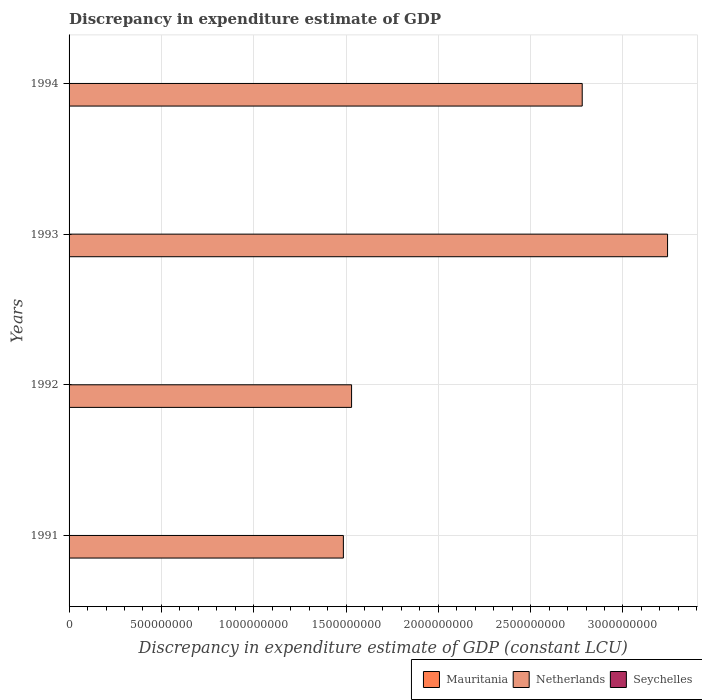How many different coloured bars are there?
Provide a succinct answer. 1. Are the number of bars per tick equal to the number of legend labels?
Offer a terse response. No. How many bars are there on the 4th tick from the bottom?
Keep it short and to the point. 1. In how many cases, is the number of bars for a given year not equal to the number of legend labels?
Provide a short and direct response. 4. Across all years, what is the maximum discrepancy in expenditure estimate of GDP in Netherlands?
Your response must be concise. 3.24e+09. What is the total discrepancy in expenditure estimate of GDP in Mauritania in the graph?
Make the answer very short. 0. What is the difference between the discrepancy in expenditure estimate of GDP in Netherlands in 1992 and that in 1993?
Keep it short and to the point. -1.71e+09. What is the difference between the discrepancy in expenditure estimate of GDP in Mauritania in 1992 and the discrepancy in expenditure estimate of GDP in Seychelles in 1994?
Your response must be concise. 0. What is the average discrepancy in expenditure estimate of GDP in Netherlands per year?
Keep it short and to the point. 2.26e+09. In how many years, is the discrepancy in expenditure estimate of GDP in Mauritania greater than 800000000 LCU?
Keep it short and to the point. 0. What is the difference between the highest and the second highest discrepancy in expenditure estimate of GDP in Netherlands?
Make the answer very short. 4.62e+08. What is the difference between the highest and the lowest discrepancy in expenditure estimate of GDP in Netherlands?
Your answer should be very brief. 1.76e+09. In how many years, is the discrepancy in expenditure estimate of GDP in Mauritania greater than the average discrepancy in expenditure estimate of GDP in Mauritania taken over all years?
Make the answer very short. 0. How many bars are there?
Your response must be concise. 4. Are all the bars in the graph horizontal?
Your response must be concise. Yes. Are the values on the major ticks of X-axis written in scientific E-notation?
Offer a very short reply. No. Does the graph contain any zero values?
Offer a very short reply. Yes. How are the legend labels stacked?
Your answer should be compact. Horizontal. What is the title of the graph?
Your response must be concise. Discrepancy in expenditure estimate of GDP. What is the label or title of the X-axis?
Your answer should be compact. Discrepancy in expenditure estimate of GDP (constant LCU). What is the label or title of the Y-axis?
Ensure brevity in your answer.  Years. What is the Discrepancy in expenditure estimate of GDP (constant LCU) in Mauritania in 1991?
Your response must be concise. 0. What is the Discrepancy in expenditure estimate of GDP (constant LCU) of Netherlands in 1991?
Ensure brevity in your answer.  1.49e+09. What is the Discrepancy in expenditure estimate of GDP (constant LCU) in Mauritania in 1992?
Provide a short and direct response. 0. What is the Discrepancy in expenditure estimate of GDP (constant LCU) in Netherlands in 1992?
Your response must be concise. 1.53e+09. What is the Discrepancy in expenditure estimate of GDP (constant LCU) in Seychelles in 1992?
Offer a very short reply. 0. What is the Discrepancy in expenditure estimate of GDP (constant LCU) in Netherlands in 1993?
Offer a very short reply. 3.24e+09. What is the Discrepancy in expenditure estimate of GDP (constant LCU) of Seychelles in 1993?
Provide a succinct answer. 0. What is the Discrepancy in expenditure estimate of GDP (constant LCU) in Mauritania in 1994?
Your answer should be compact. 0. What is the Discrepancy in expenditure estimate of GDP (constant LCU) of Netherlands in 1994?
Give a very brief answer. 2.78e+09. Across all years, what is the maximum Discrepancy in expenditure estimate of GDP (constant LCU) in Netherlands?
Your response must be concise. 3.24e+09. Across all years, what is the minimum Discrepancy in expenditure estimate of GDP (constant LCU) of Netherlands?
Your answer should be very brief. 1.49e+09. What is the total Discrepancy in expenditure estimate of GDP (constant LCU) of Mauritania in the graph?
Provide a short and direct response. 0. What is the total Discrepancy in expenditure estimate of GDP (constant LCU) of Netherlands in the graph?
Offer a terse response. 9.04e+09. What is the total Discrepancy in expenditure estimate of GDP (constant LCU) of Seychelles in the graph?
Your response must be concise. 0. What is the difference between the Discrepancy in expenditure estimate of GDP (constant LCU) of Netherlands in 1991 and that in 1992?
Ensure brevity in your answer.  -4.44e+07. What is the difference between the Discrepancy in expenditure estimate of GDP (constant LCU) of Netherlands in 1991 and that in 1993?
Offer a terse response. -1.76e+09. What is the difference between the Discrepancy in expenditure estimate of GDP (constant LCU) of Netherlands in 1991 and that in 1994?
Provide a short and direct response. -1.29e+09. What is the difference between the Discrepancy in expenditure estimate of GDP (constant LCU) of Netherlands in 1992 and that in 1993?
Your answer should be very brief. -1.71e+09. What is the difference between the Discrepancy in expenditure estimate of GDP (constant LCU) of Netherlands in 1992 and that in 1994?
Provide a short and direct response. -1.25e+09. What is the difference between the Discrepancy in expenditure estimate of GDP (constant LCU) of Netherlands in 1993 and that in 1994?
Your response must be concise. 4.62e+08. What is the average Discrepancy in expenditure estimate of GDP (constant LCU) in Netherlands per year?
Offer a very short reply. 2.26e+09. What is the ratio of the Discrepancy in expenditure estimate of GDP (constant LCU) in Netherlands in 1991 to that in 1993?
Ensure brevity in your answer.  0.46. What is the ratio of the Discrepancy in expenditure estimate of GDP (constant LCU) in Netherlands in 1991 to that in 1994?
Provide a succinct answer. 0.53. What is the ratio of the Discrepancy in expenditure estimate of GDP (constant LCU) in Netherlands in 1992 to that in 1993?
Your response must be concise. 0.47. What is the ratio of the Discrepancy in expenditure estimate of GDP (constant LCU) in Netherlands in 1992 to that in 1994?
Offer a very short reply. 0.55. What is the ratio of the Discrepancy in expenditure estimate of GDP (constant LCU) in Netherlands in 1993 to that in 1994?
Your answer should be very brief. 1.17. What is the difference between the highest and the second highest Discrepancy in expenditure estimate of GDP (constant LCU) of Netherlands?
Ensure brevity in your answer.  4.62e+08. What is the difference between the highest and the lowest Discrepancy in expenditure estimate of GDP (constant LCU) of Netherlands?
Give a very brief answer. 1.76e+09. 